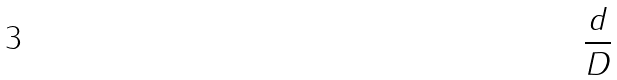Convert formula to latex. <formula><loc_0><loc_0><loc_500><loc_500>\frac { d } { D }</formula> 